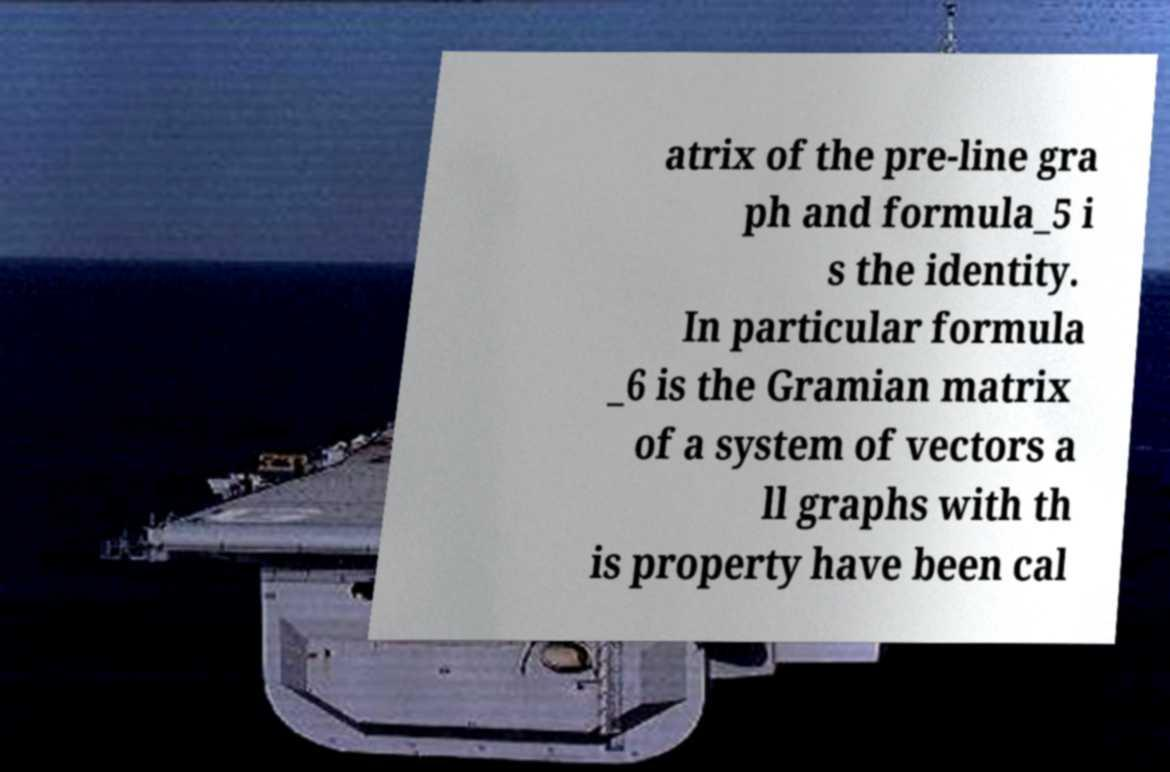Could you extract and type out the text from this image? atrix of the pre-line gra ph and formula_5 i s the identity. In particular formula _6 is the Gramian matrix of a system of vectors a ll graphs with th is property have been cal 